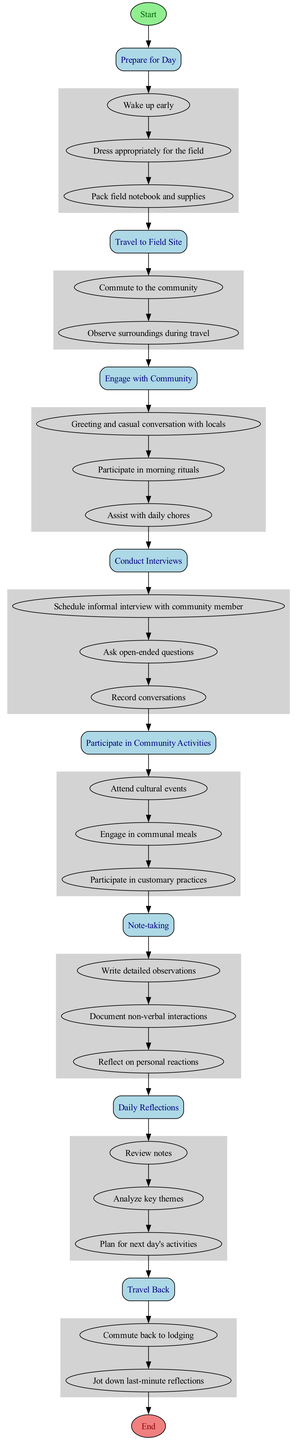What is the first activity listed in the diagram? The first activity in the diagram is labeled as "Prepare for Day", which is the first rectangle node following the Start node.
Answer: Prepare for Day How many activities are represented in the diagram? The diagram notes eight distinct activities, as observed from the eight rectangles between the Start and End nodes.
Answer: Eight Which activity directly follows "Engage with Community"? The activity that comes directly after "Engage with Community" is "Conduct Interviews". This can be traced by following the edges from the first mentioned activity to the next in the diagram.
Answer: Conduct Interviews What is the last action under "Daily Reflections"? The last action under "Daily Reflections" is "Plan for next day's activities", which is the final entry in the Action box associated with that activity.
Answer: Plan for next day's activities After which activity is the "Travel Back" activity positioned? The "Travel Back" activity is positioned after the "Daily Reflections" activity, meaning it follows the reflections made about the day’s observations.
Answer: Daily Reflections How many actions are listed under "Note-taking"? There are three actions listed under "Note-taking", confirmed by counting the items in the Action box associated with that activity.
Answer: Three Which activity involves scheduling interviews? The activity that includes scheduling interviews is "Conduct Interviews", as indicated by the specific action "Schedule informal interview with community member" listed under it.
Answer: Conduct Interviews What is the final node in the diagram? The final node in the diagram is labeled "End", which indicates the conclusion of the day's activities, positioned at the bottom of the flow.
Answer: End 